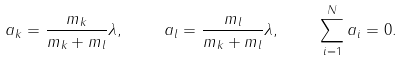<formula> <loc_0><loc_0><loc_500><loc_500>a _ { k } = \frac { m _ { k } } { m _ { k } + m _ { l } } \lambda , \quad \ a _ { l } = \frac { m _ { l } } { m _ { k } + m _ { l } } \lambda , \quad \ \sum _ { i = 1 } ^ { N } a _ { i } = 0 .</formula> 